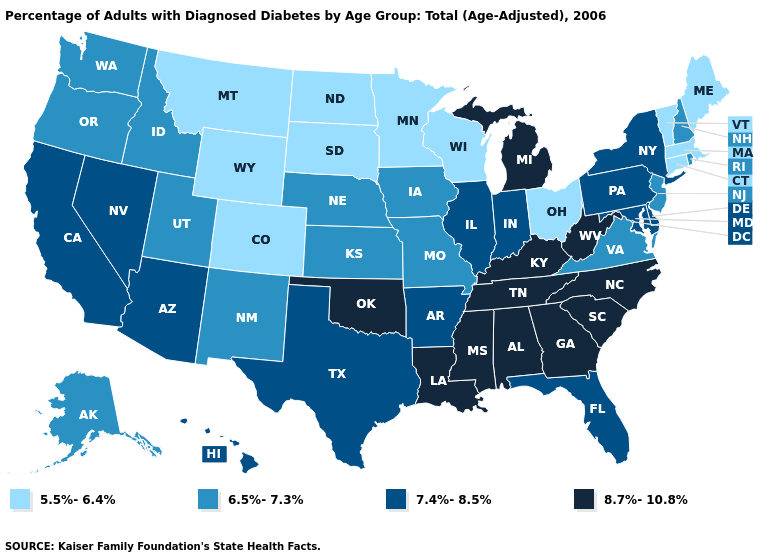Name the states that have a value in the range 8.7%-10.8%?
Be succinct. Alabama, Georgia, Kentucky, Louisiana, Michigan, Mississippi, North Carolina, Oklahoma, South Carolina, Tennessee, West Virginia. Among the states that border Virginia , does West Virginia have the highest value?
Answer briefly. Yes. Among the states that border West Virginia , does Pennsylvania have the lowest value?
Keep it brief. No. Does Vermont have the highest value in the USA?
Write a very short answer. No. Is the legend a continuous bar?
Be succinct. No. What is the lowest value in the USA?
Be succinct. 5.5%-6.4%. What is the lowest value in states that border New York?
Write a very short answer. 5.5%-6.4%. Which states hav the highest value in the Northeast?
Be succinct. New York, Pennsylvania. What is the lowest value in the USA?
Give a very brief answer. 5.5%-6.4%. Name the states that have a value in the range 6.5%-7.3%?
Keep it brief. Alaska, Idaho, Iowa, Kansas, Missouri, Nebraska, New Hampshire, New Jersey, New Mexico, Oregon, Rhode Island, Utah, Virginia, Washington. What is the value of Alaska?
Concise answer only. 6.5%-7.3%. Name the states that have a value in the range 7.4%-8.5%?
Answer briefly. Arizona, Arkansas, California, Delaware, Florida, Hawaii, Illinois, Indiana, Maryland, Nevada, New York, Pennsylvania, Texas. What is the value of New Jersey?
Write a very short answer. 6.5%-7.3%. Name the states that have a value in the range 5.5%-6.4%?
Short answer required. Colorado, Connecticut, Maine, Massachusetts, Minnesota, Montana, North Dakota, Ohio, South Dakota, Vermont, Wisconsin, Wyoming. 